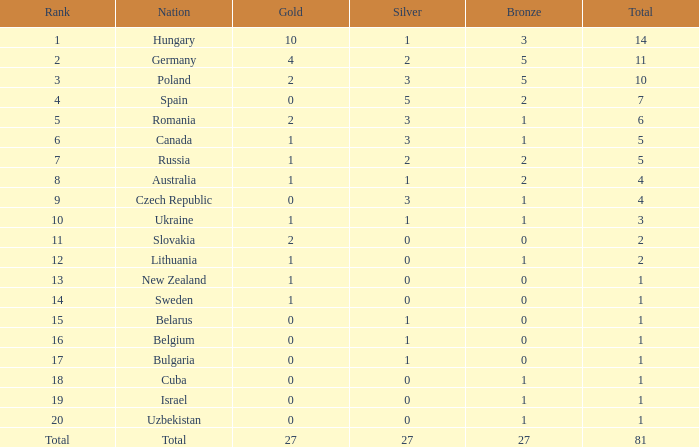For germany, when there is over 1 gold, under 3 silver, and a total above 11, what is the bronze count? 0.0. 